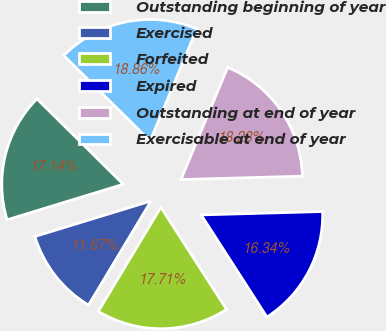Convert chart. <chart><loc_0><loc_0><loc_500><loc_500><pie_chart><fcel>Outstanding beginning of year<fcel>Exercised<fcel>Forfeited<fcel>Expired<fcel>Outstanding at end of year<fcel>Exercisable at end of year<nl><fcel>17.14%<fcel>11.67%<fcel>17.71%<fcel>16.34%<fcel>18.28%<fcel>18.86%<nl></chart> 